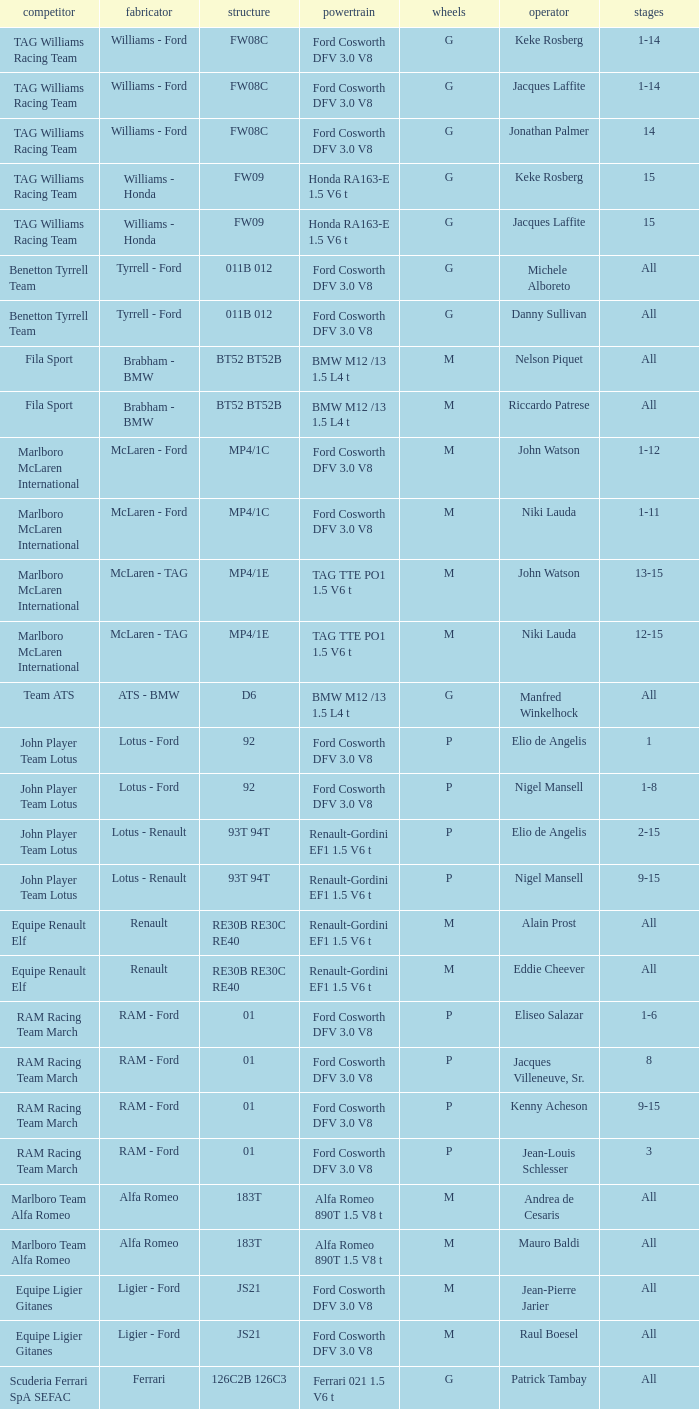Who is the Constructor for driver Piercarlo Ghinzani and a Ford cosworth dfv 3.0 v8 engine? Osella - Ford. 